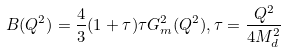Convert formula to latex. <formula><loc_0><loc_0><loc_500><loc_500>B ( Q ^ { 2 } ) = \frac { 4 } { 3 } ( 1 + \tau ) \tau G _ { m } ^ { 2 } ( Q ^ { 2 } ) , \tau = \frac { Q ^ { 2 } } { 4 M ^ { 2 } _ { d } }</formula> 